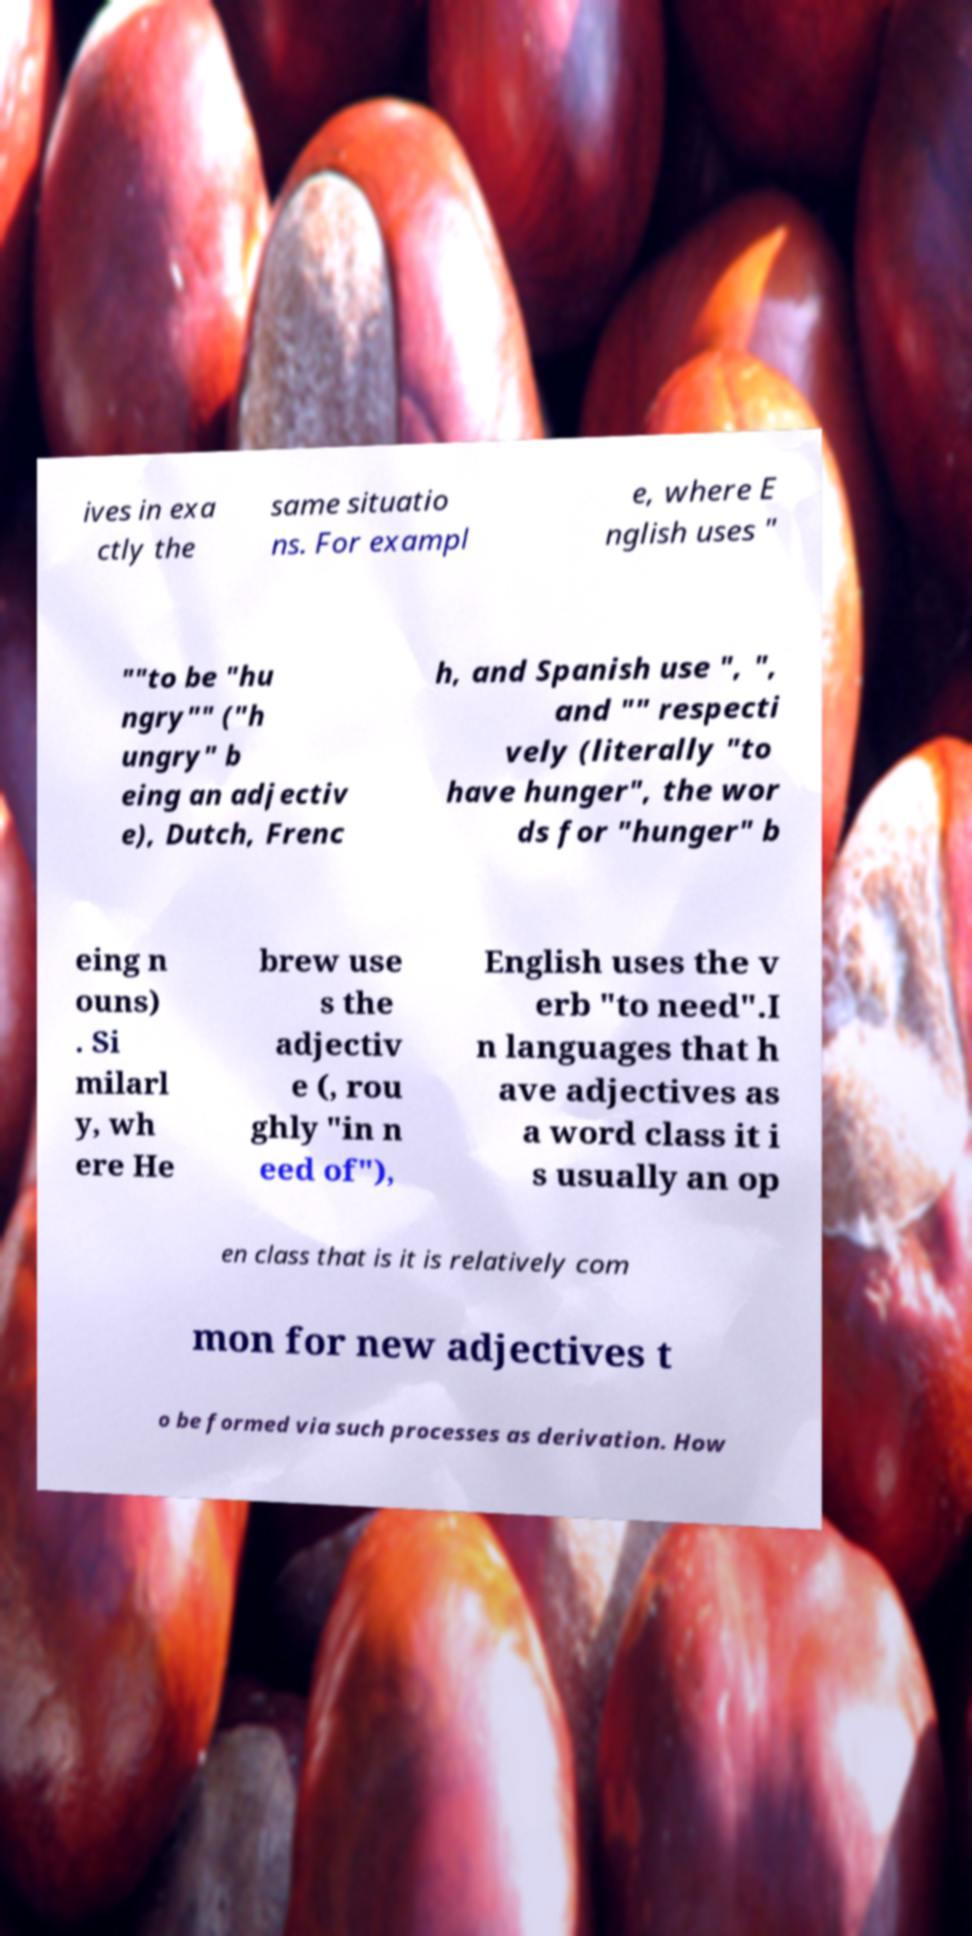There's text embedded in this image that I need extracted. Can you transcribe it verbatim? ives in exa ctly the same situatio ns. For exampl e, where E nglish uses " ""to be "hu ngry"" ("h ungry" b eing an adjectiv e), Dutch, Frenc h, and Spanish use ", ", and "" respecti vely (literally "to have hunger", the wor ds for "hunger" b eing n ouns) . Si milarl y, wh ere He brew use s the adjectiv e (, rou ghly "in n eed of"), English uses the v erb "to need".I n languages that h ave adjectives as a word class it i s usually an op en class that is it is relatively com mon for new adjectives t o be formed via such processes as derivation. How 